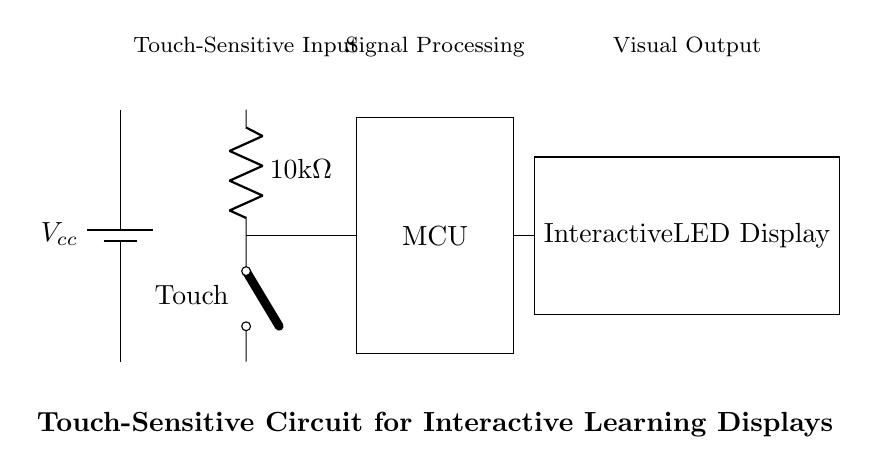What does the battery represent in this circuit? The battery represents the power supply, providing the necessary voltage for the circuit to operate. In this circuit, it serves as the source of energy needed for the touch sensor, microcontroller, and LED display to function.
Answer: power supply What is the resistance value of the resistor in the circuit? The resistor in the circuit has a resistance value of 10k ohms, as labeled next to it. This indicates the resistance it provides in the circuit, affecting how much current flows through the touch sensor.
Answer: 10k ohms What is the function of the touch sensor in the circuit? The touch sensor serves as the input device, allowing user interaction. When a user touches the sensor, it closes the switch, enabling current flow and sending a signal to the microcontroller to process the input.
Answer: input device How does the microcontroller interact with the components? The microcontroller processes signals received from the touch sensor and controls the output to the LED display based on these inputs. It acts as the central processing unit, interpreting touch input and directing actions accordingly.
Answer: processes signals What type of output does the LED display provide? The LED display provides a visual output that responds to the processed signals from the microcontroller, indicating actions or information based on user interactions. This output can vary depending on the signals received.
Answer: visual output 